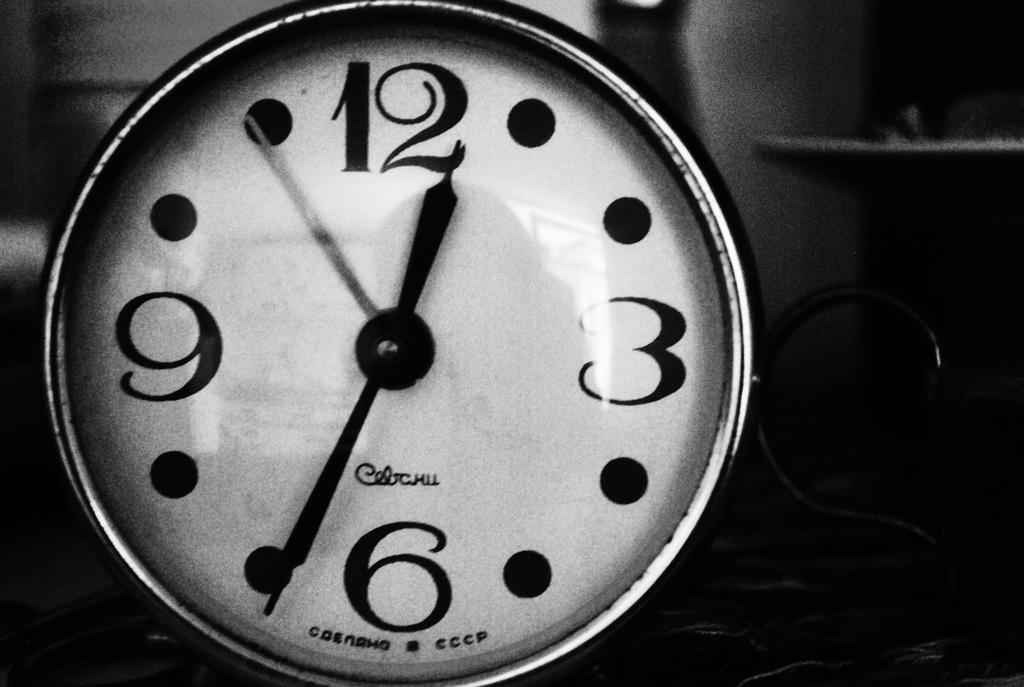<image>
Relay a brief, clear account of the picture shown. A round clock that says CCCP at the bottom and only has four numbers on the face. 